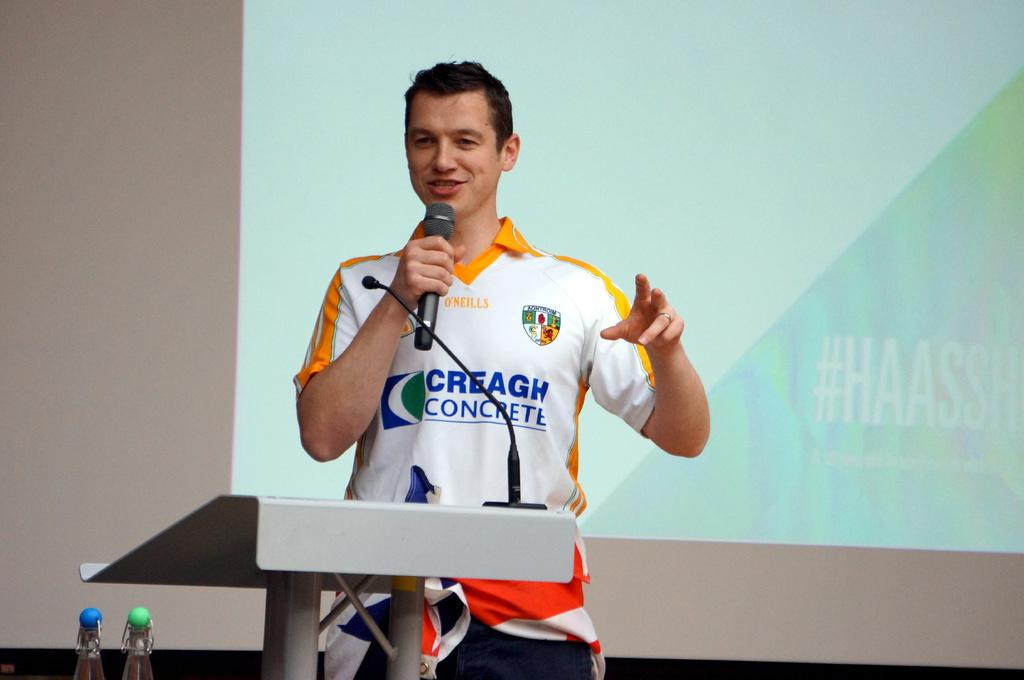<image>
Offer a succinct explanation of the picture presented. A man is talking into a microphone, his shirt advertises concrete. 